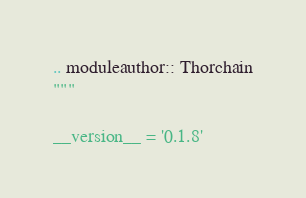Convert code to text. <code><loc_0><loc_0><loc_500><loc_500><_Python_>.. moduleauthor:: Thorchain
"""

__version__ = '0.1.8'</code> 